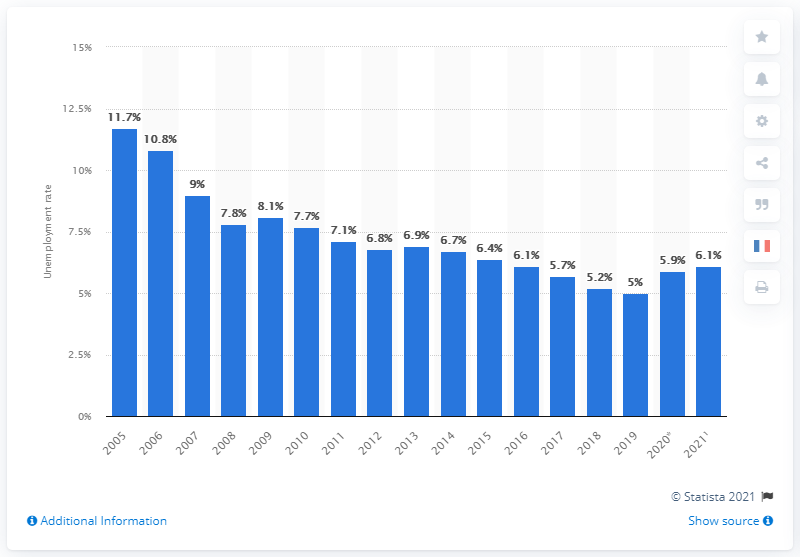Draw attention to some important aspects in this diagram. In 2021, the unemployment rate in Germany was reported to be 6.1%. 